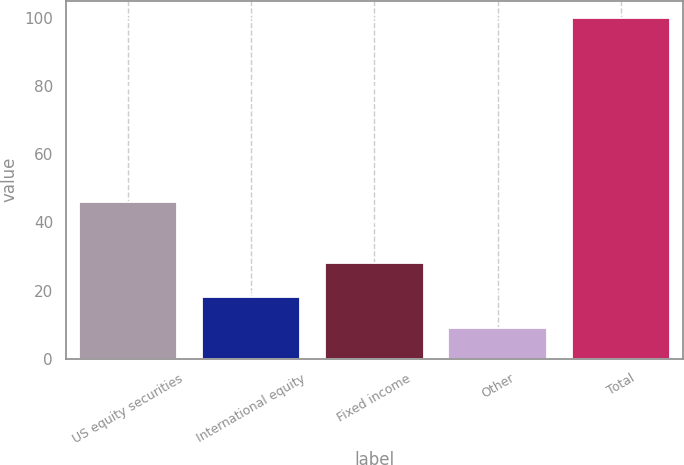Convert chart to OTSL. <chart><loc_0><loc_0><loc_500><loc_500><bar_chart><fcel>US equity securities<fcel>International equity<fcel>Fixed income<fcel>Other<fcel>Total<nl><fcel>46<fcel>18.1<fcel>28<fcel>9<fcel>100<nl></chart> 